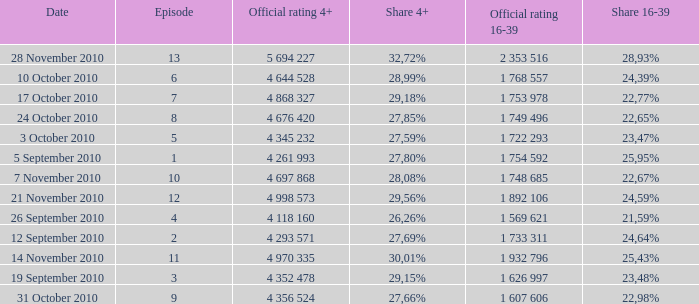What is the 16-39 share of the episode with a 4+ share of 30,01%? 25,43%. 